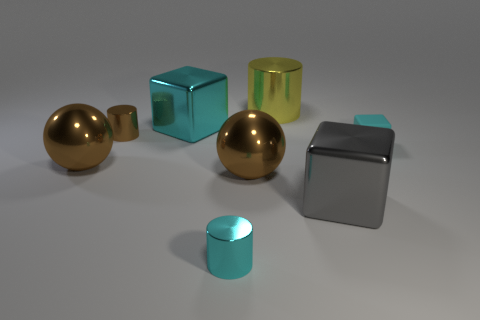What can you infer about the lighting in the scene? The lighting in the scene is soft and diffused, casting gentle shadows underneath the objects. The way the light reflects off the metallic surfaces suggests a single, possibly overhead light source. 